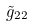Convert formula to latex. <formula><loc_0><loc_0><loc_500><loc_500>\tilde { g } _ { 2 2 }</formula> 